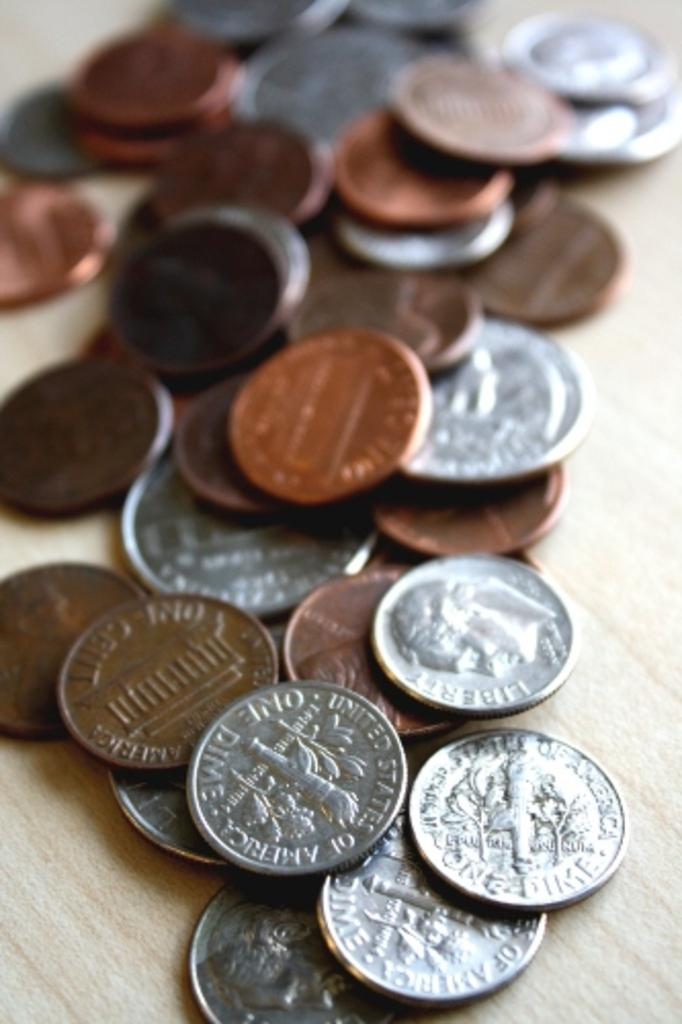What objects are present in the image? There are coins in the image. What is the coins placed on? The coins are on a wooden surface. What question does the stranger ask about the coins in the image? There is no stranger present in the image, and therefore no question can be asked about the coins. 